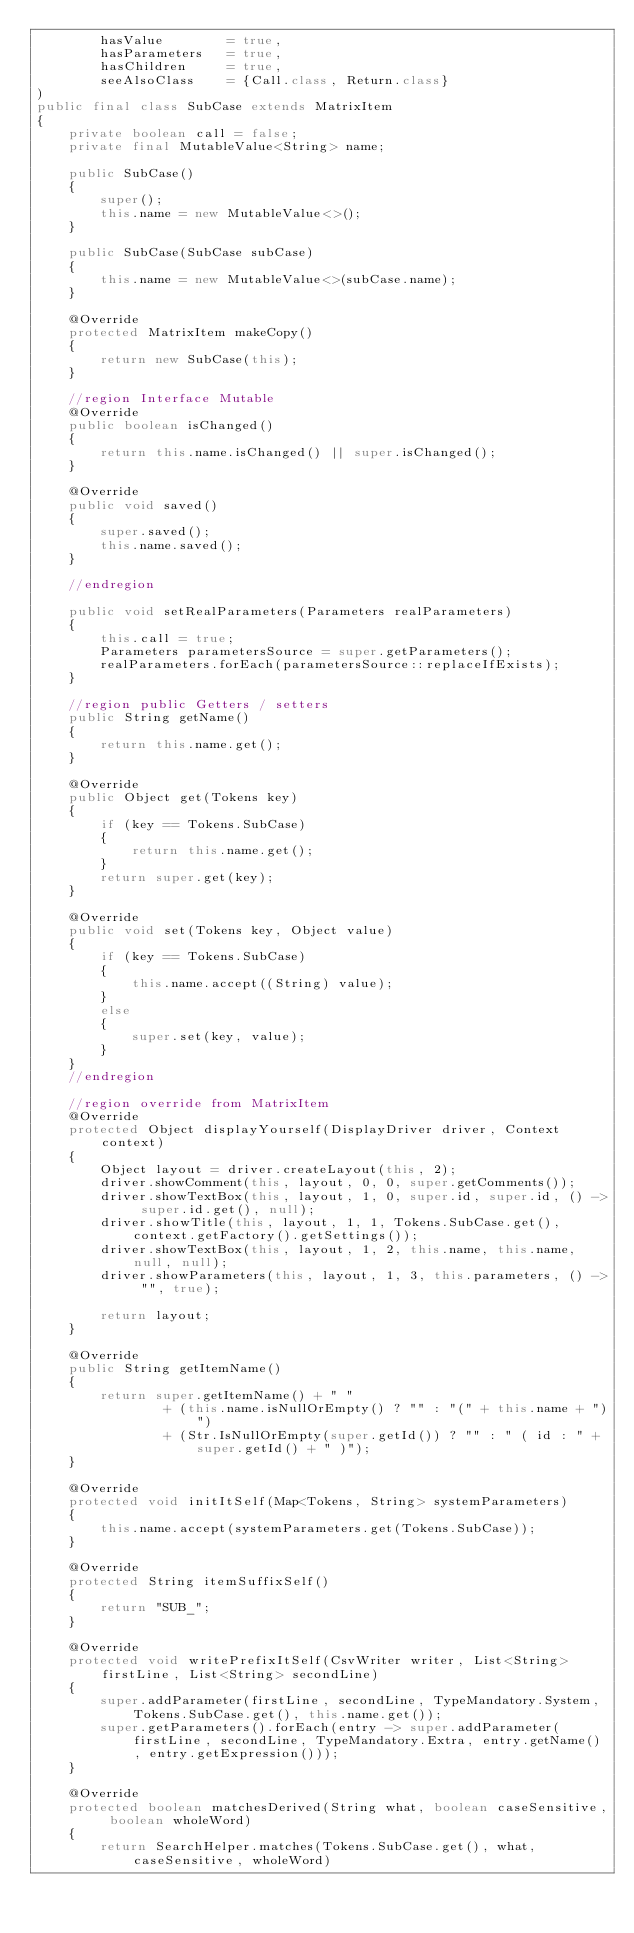Convert code to text. <code><loc_0><loc_0><loc_500><loc_500><_Java_>        hasValue 		= true,
        hasParameters 	= true,
        hasChildren 	= true,
		seeAlsoClass 	= {Call.class, Return.class}
)
public final class SubCase extends MatrixItem
{
	private boolean call = false;
	private final MutableValue<String> name;

	public SubCase()
	{
		super();
		this.name = new MutableValue<>();
	}

	public SubCase(SubCase subCase)
	{
		this.name = new MutableValue<>(subCase.name);
	}

	@Override
	protected MatrixItem makeCopy()
	{
		return new SubCase(this);
	}

	//region Interface Mutable
	@Override
	public boolean isChanged()
	{
		return this.name.isChanged() || super.isChanged();
	}

	@Override
	public void saved()
	{
		super.saved();
		this.name.saved();
	}

	//endregion

	public void setRealParameters(Parameters realParameters)
	{
		this.call = true;
		Parameters parametersSource = super.getParameters();
		realParameters.forEach(parametersSource::replaceIfExists);
	}

	//region public Getters / setters
	public String getName()
	{
		return this.name.get();
	}

	@Override
	public Object get(Tokens key)
	{
		if (key == Tokens.SubCase)
		{
			return this.name.get();
		}
		return super.get(key);
	}

	@Override
	public void set(Tokens key, Object value)
	{
		if (key == Tokens.SubCase)
		{
			this.name.accept((String) value);
		}
		else
		{
			super.set(key, value);
		}
	}
	//endregion

	//region override from MatrixItem
	@Override
	protected Object displayYourself(DisplayDriver driver, Context context)
	{
		Object layout = driver.createLayout(this, 2);
		driver.showComment(this, layout, 0, 0, super.getComments());
		driver.showTextBox(this, layout, 1, 0, super.id, super.id, () -> super.id.get(), null);
		driver.showTitle(this, layout, 1, 1, Tokens.SubCase.get(), context.getFactory().getSettings());
		driver.showTextBox(this, layout, 1, 2, this.name, this.name, null, null);
		driver.showParameters(this, layout, 1, 3, this.parameters, () -> "", true);

		return layout;
	}

	@Override
	public String getItemName()
	{
		return super.getItemName() + " "
				+ (this.name.isNullOrEmpty() ? "" : "(" + this.name + ")")
				+ (Str.IsNullOrEmpty(super.getId()) ? "" : " ( id : " + super.getId() + " )");
	}

	@Override
	protected void initItSelf(Map<Tokens, String> systemParameters)
	{
		this.name.accept(systemParameters.get(Tokens.SubCase));
	}

	@Override
	protected String itemSuffixSelf()
	{
		return "SUB_";
	}

	@Override
	protected void writePrefixItSelf(CsvWriter writer, List<String> firstLine, List<String> secondLine)
	{
		super.addParameter(firstLine, secondLine, TypeMandatory.System, Tokens.SubCase.get(), this.name.get());
		super.getParameters().forEach(entry -> super.addParameter(firstLine, secondLine, TypeMandatory.Extra, entry.getName(), entry.getExpression()));
	}

	@Override
	protected boolean matchesDerived(String what, boolean caseSensitive, boolean wholeWord)
	{
		return SearchHelper.matches(Tokens.SubCase.get(), what, caseSensitive, wholeWord)</code> 